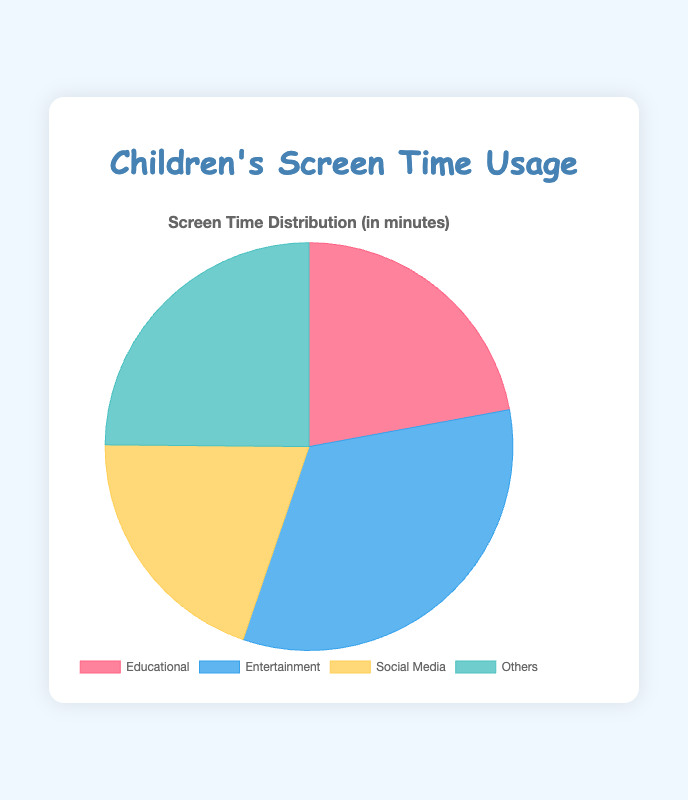What percentage of screen time is used for Entertainment? The pie chart shows that the Entertainment category accounts for 60 minutes of screen time. The total screen time usage is the sum of all categories: 40 (Educational) + 60 (Entertainment) + 36 (Social Media) + 45 (Others) = 181 minutes. So, the percentage for Entertainment is (60 / 181) * 100 ≈ 33.15%.
Answer: 33.15% Which category has the least screen time usage? From the pie chart, Social Media has the smallest section, representing 36 minutes.
Answer: Social Media What is the difference in screen time between Educational and Social Media content? Educational content amounts to 40 minutes while Social Media usage is 36 minutes. Therefore, the difference is 40 - 36 = 4 minutes.
Answer: 4 minutes How does the screen time for Others compare to that of Educational content? The screen time for Educational content is 40 minutes and for Others is 45 minutes. Thus, Others has 45 - 40 = 5 minutes more screen time than Educational content.
Answer: 5 minutes more What fraction of the total screen time is dedicated to Educational content? The total screen time is 181 minutes. Educational content is 40 minutes out of 181. Therefore, the fraction is 40/181, which simplifies to approximately 22.10%.
Answer: 22.10% If the screen time for Social Media increased by 50%, how much would it be? The current screen time for Social Media is 36 minutes. Increasing this by 50% is calculated as 36 * 1.5 = 54 minutes.
Answer: 54 minutes How many more minutes are spent on Entertainment compared to Social Media and Others combined? Social Media usage is 36 minutes and Others usage is 45 minutes, totaling 36 + 45 = 81 minutes. Entertainment is 60 minutes, so the difference is 60 - 81 = -21 minutes, indicating that Entertainment is actually 21 minutes less than Social Media and Others combined.
Answer: -21 minutes What is the average screen time per content type? To find the average screen time, total the minutes of all categories: 181 minutes. There are 4 content types, so the average is 181 / 4 = 45.25 minutes per content type.
Answer: 45.25 minutes 